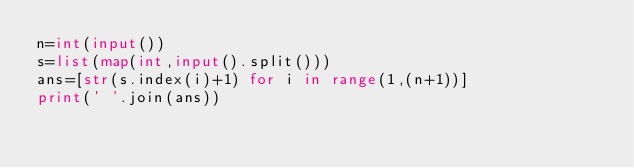<code> <loc_0><loc_0><loc_500><loc_500><_Python_>n=int(input())
s=list(map(int,input().split()))
ans=[str(s.index(i)+1) for i in range(1,(n+1))]
print(' '.join(ans))</code> 